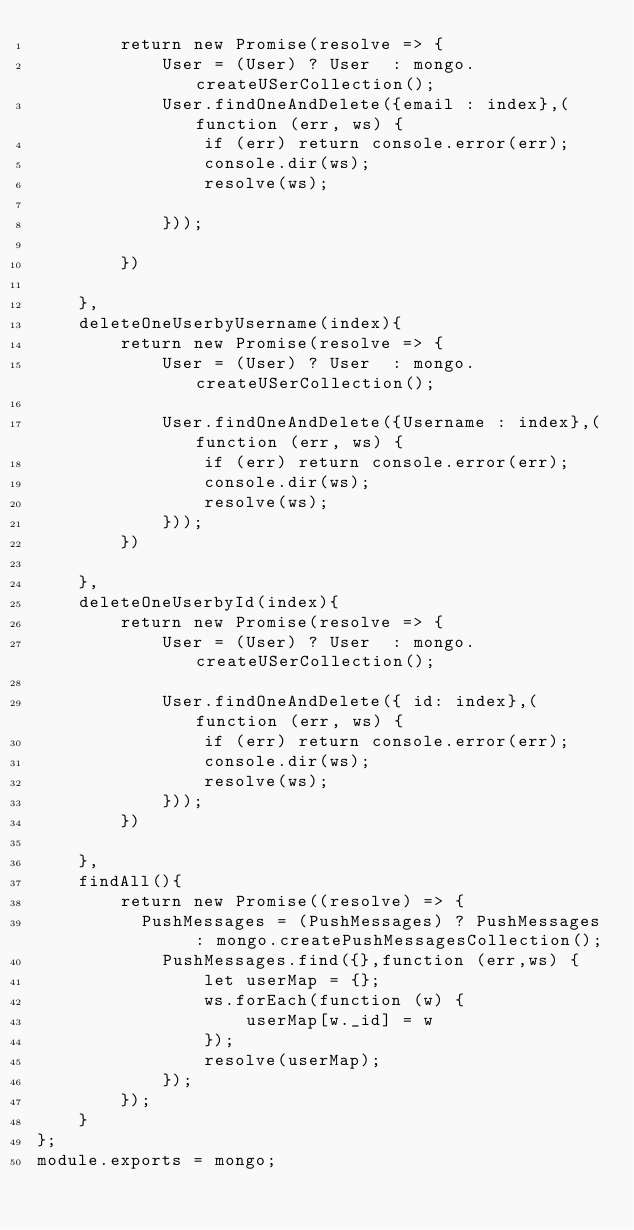Convert code to text. <code><loc_0><loc_0><loc_500><loc_500><_JavaScript_>        return new Promise(resolve => {
            User = (User) ? User  : mongo.createUSerCollection();
            User.findOneAndDelete({email : index},(function (err, ws) {
                if (err) return console.error(err);
                console.dir(ws);
                resolve(ws);

            }));

        })

    },
    deleteOneUserbyUsername(index){
        return new Promise(resolve => {
            User = (User) ? User  : mongo.createUSerCollection();

            User.findOneAndDelete({Username : index},(function (err, ws) {
                if (err) return console.error(err);
                console.dir(ws);
                resolve(ws);
            }));
        })

    },
    deleteOneUserbyId(index){
        return new Promise(resolve => {
            User = (User) ? User  : mongo.createUSerCollection();

            User.findOneAndDelete({ id: index},(function (err, ws) {
                if (err) return console.error(err);
                console.dir(ws);
                resolve(ws);
            }));
        })

    },
    findAll(){
        return new Promise((resolve) => {
          PushMessages = (PushMessages) ? PushMessages  : mongo.createPushMessagesCollection();
            PushMessages.find({},function (err,ws) {
                let userMap = {};
                ws.forEach(function (w) {
                    userMap[w._id] = w
                });
                resolve(userMap);
            });
        });
    }
};
module.exports = mongo;
</code> 